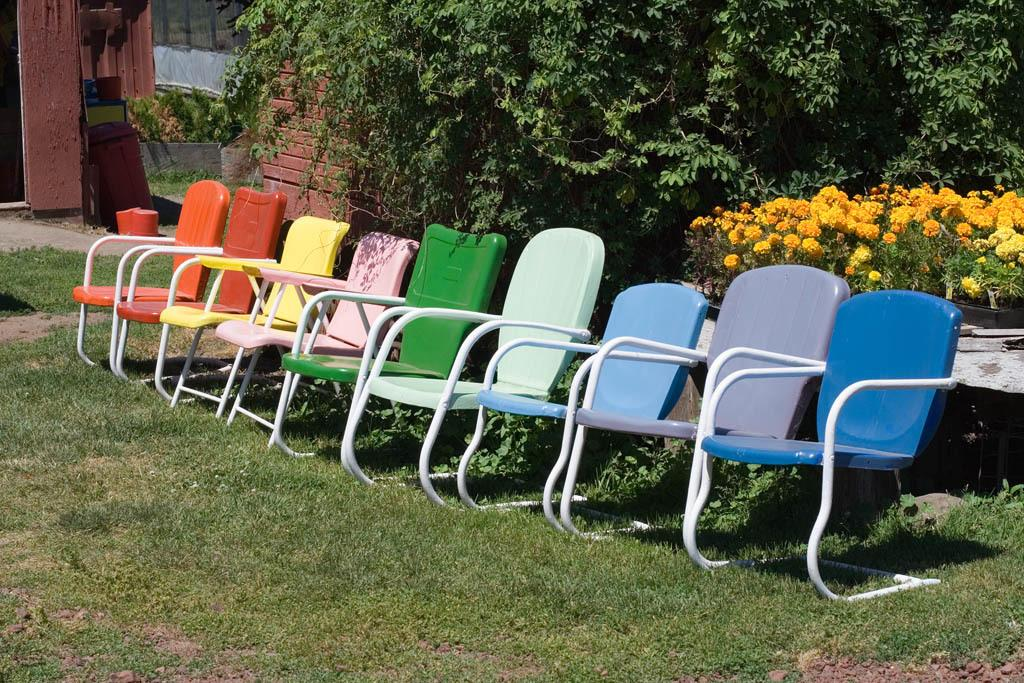What is the main subject of the image? The main subject of the image is empty chairs. Where are the chairs located? The chairs are on the grass. What can be seen in the background of the image? There are flowers and trees in the background of the image. What letters are being rewarded for their excellent oil production in the image? There are no letters, oil, or rewards mentioned or depicted in the image. 